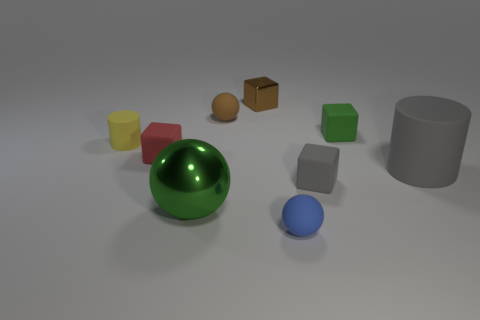Is the number of tiny brown balls that are on the left side of the tiny yellow rubber cylinder greater than the number of metal spheres?
Your answer should be very brief. No. There is a matte cylinder right of the matte cylinder to the left of the blue thing; what is its color?
Your response must be concise. Gray. What number of things are either tiny brown things that are in front of the brown shiny object or cylinders behind the large matte thing?
Make the answer very short. 2. The large rubber cylinder is what color?
Provide a short and direct response. Gray. How many small blue things have the same material as the blue sphere?
Your answer should be compact. 0. Is the number of small green shiny cubes greater than the number of tiny green matte blocks?
Your answer should be very brief. No. How many big metal balls are behind the metallic sphere that is in front of the large gray cylinder?
Make the answer very short. 0. How many objects are either small brown objects behind the tiny yellow cylinder or yellow matte cubes?
Offer a very short reply. 2. Are there any gray things of the same shape as the large green metallic object?
Your answer should be very brief. No. There is a small brown matte thing behind the matte ball on the right side of the brown matte ball; what shape is it?
Ensure brevity in your answer.  Sphere. 